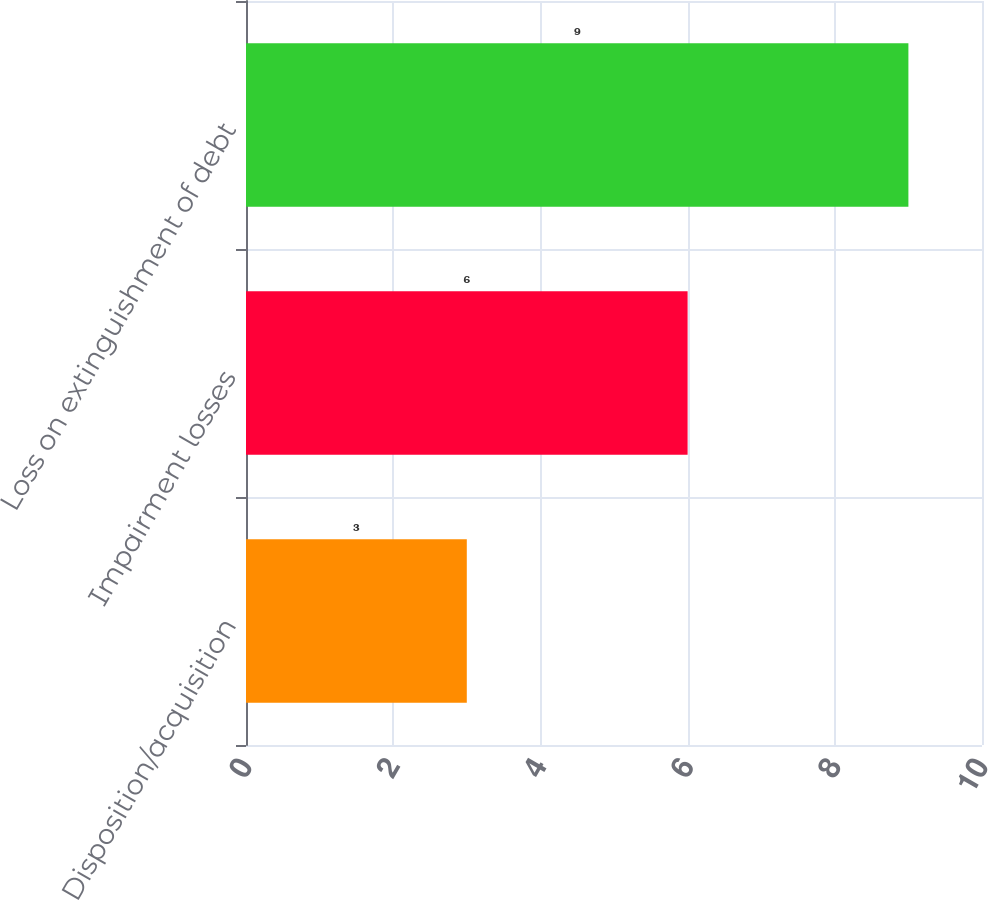<chart> <loc_0><loc_0><loc_500><loc_500><bar_chart><fcel>Disposition/acquisition<fcel>Impairment losses<fcel>Loss on extinguishment of debt<nl><fcel>3<fcel>6<fcel>9<nl></chart> 